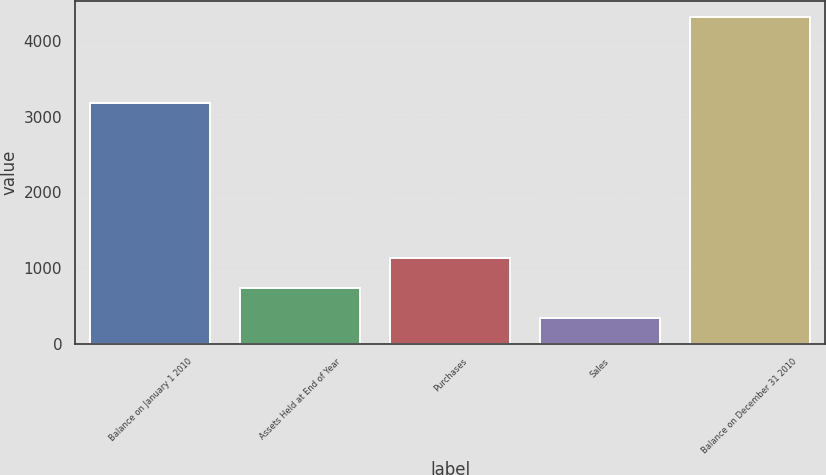Convert chart. <chart><loc_0><loc_0><loc_500><loc_500><bar_chart><fcel>Balance on January 1 2010<fcel>Assets Held at End of Year<fcel>Purchases<fcel>Sales<fcel>Balance on December 31 2010<nl><fcel>3180<fcel>741<fcel>1138<fcel>344<fcel>4314<nl></chart> 